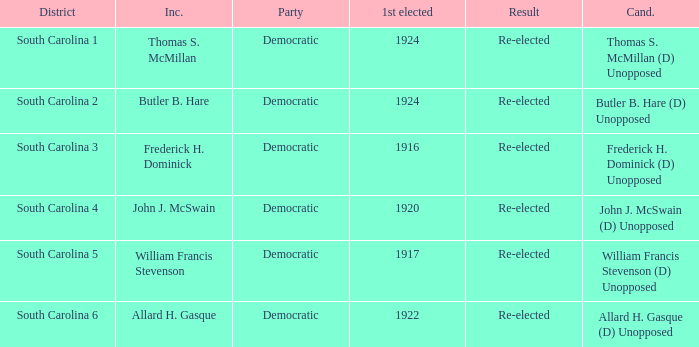What is the party for south carolina 3? Democratic. Can you give me this table as a dict? {'header': ['District', 'Inc.', 'Party', '1st elected', 'Result', 'Cand.'], 'rows': [['South Carolina 1', 'Thomas S. McMillan', 'Democratic', '1924', 'Re-elected', 'Thomas S. McMillan (D) Unopposed'], ['South Carolina 2', 'Butler B. Hare', 'Democratic', '1924', 'Re-elected', 'Butler B. Hare (D) Unopposed'], ['South Carolina 3', 'Frederick H. Dominick', 'Democratic', '1916', 'Re-elected', 'Frederick H. Dominick (D) Unopposed'], ['South Carolina 4', 'John J. McSwain', 'Democratic', '1920', 'Re-elected', 'John J. McSwain (D) Unopposed'], ['South Carolina 5', 'William Francis Stevenson', 'Democratic', '1917', 'Re-elected', 'William Francis Stevenson (D) Unopposed'], ['South Carolina 6', 'Allard H. Gasque', 'Democratic', '1922', 'Re-elected', 'Allard H. Gasque (D) Unopposed']]} 